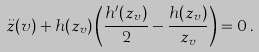Convert formula to latex. <formula><loc_0><loc_0><loc_500><loc_500>\ddot { z } ( v ) + h ( z _ { v } ) \left ( { \frac { h ^ { \prime } ( z _ { v } ) } { 2 } } - { \frac { h ( z _ { v } ) } { z _ { v } } } \right ) = 0 \, .</formula> 